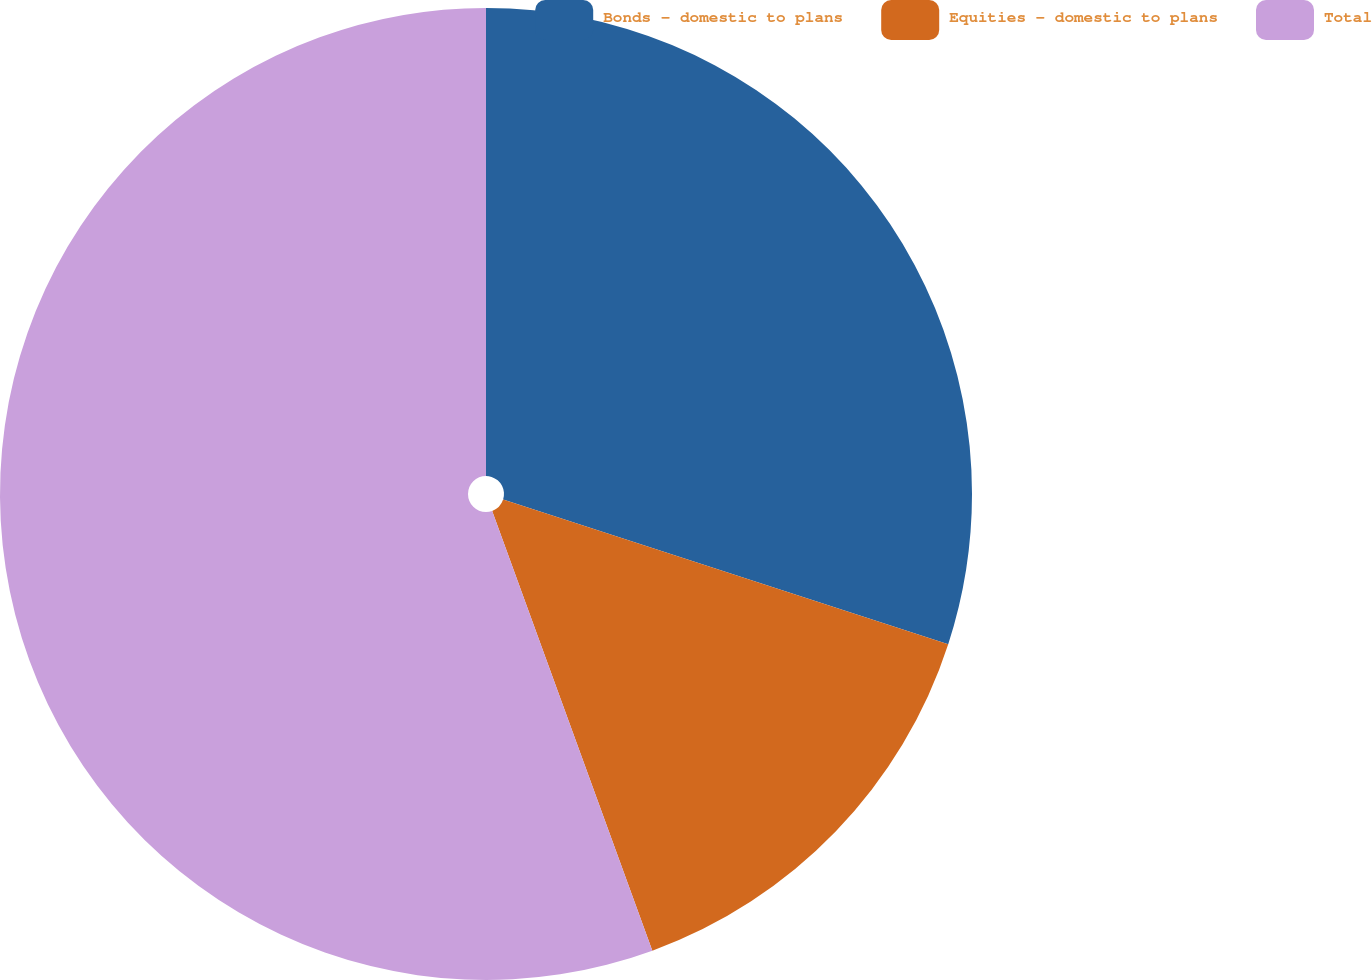Convert chart to OTSL. <chart><loc_0><loc_0><loc_500><loc_500><pie_chart><fcel>Bonds - domestic to plans<fcel>Equities - domestic to plans<fcel>Total<nl><fcel>30.0%<fcel>14.44%<fcel>55.56%<nl></chart> 